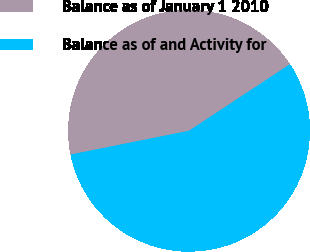Convert chart. <chart><loc_0><loc_0><loc_500><loc_500><pie_chart><fcel>Balance as of January 1 2010<fcel>Balance as of and Activity for<nl><fcel>43.88%<fcel>56.12%<nl></chart> 